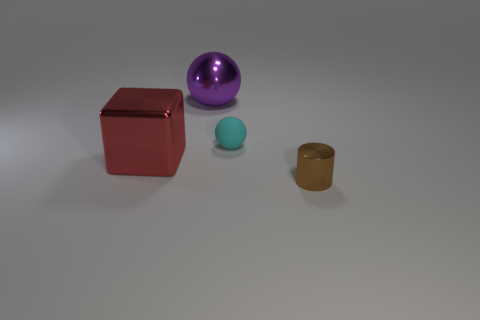Is there any other thing that is made of the same material as the tiny ball?
Your answer should be compact. No. There is a large metal object behind the red block; is it the same color as the tiny thing that is behind the tiny metallic cylinder?
Keep it short and to the point. No. Is the number of small metallic objects that are left of the brown object greater than the number of big brown rubber things?
Ensure brevity in your answer.  No. There is a metal thing left of the shiny sphere; is its size the same as the brown shiny cylinder?
Provide a short and direct response. No. Is there a cyan ball of the same size as the red thing?
Give a very brief answer. No. What color is the metallic object in front of the big red object?
Offer a terse response. Brown. What is the shape of the thing that is to the right of the large purple sphere and behind the small brown metallic object?
Your answer should be compact. Sphere. How many big red objects have the same shape as the cyan rubber thing?
Make the answer very short. 0. How many rubber spheres are there?
Make the answer very short. 1. What is the size of the thing that is behind the big red thing and on the left side of the rubber sphere?
Keep it short and to the point. Large. 